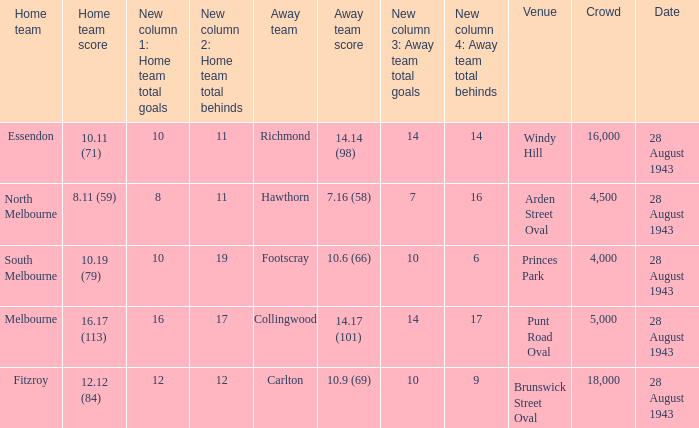11 (59)? 28 August 1943. 